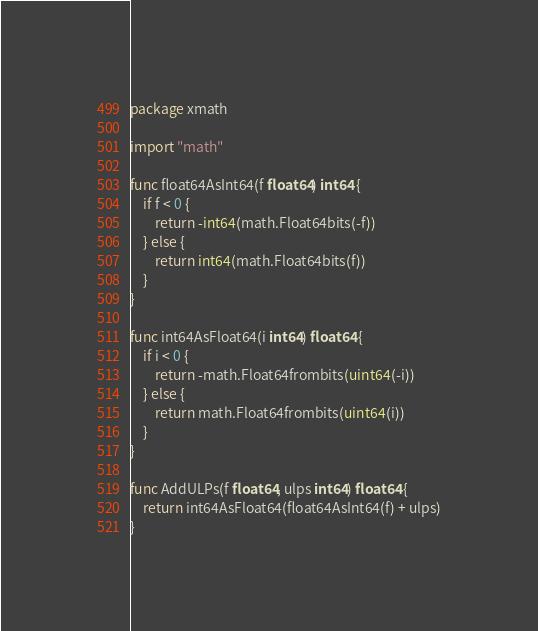<code> <loc_0><loc_0><loc_500><loc_500><_Go_>package xmath

import "math"

func float64AsInt64(f float64) int64 {
	if f < 0 {
		return -int64(math.Float64bits(-f))
	} else {
		return int64(math.Float64bits(f))
	}
}

func int64AsFloat64(i int64) float64 {
	if i < 0 {
		return -math.Float64frombits(uint64(-i))
	} else {
		return math.Float64frombits(uint64(i))
	}
}

func AddULPs(f float64, ulps int64) float64 {
	return int64AsFloat64(float64AsInt64(f) + ulps)
}
</code> 